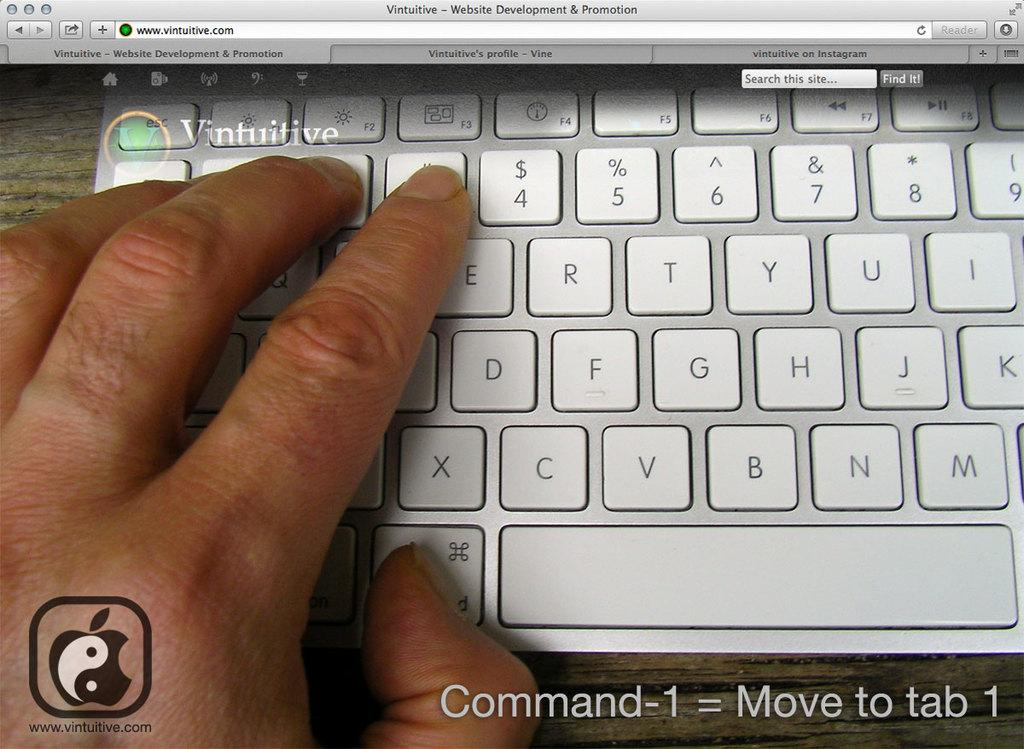<image>
Give a short and clear explanation of the subsequent image. a website for vintuitive has a keyboard on the screen 